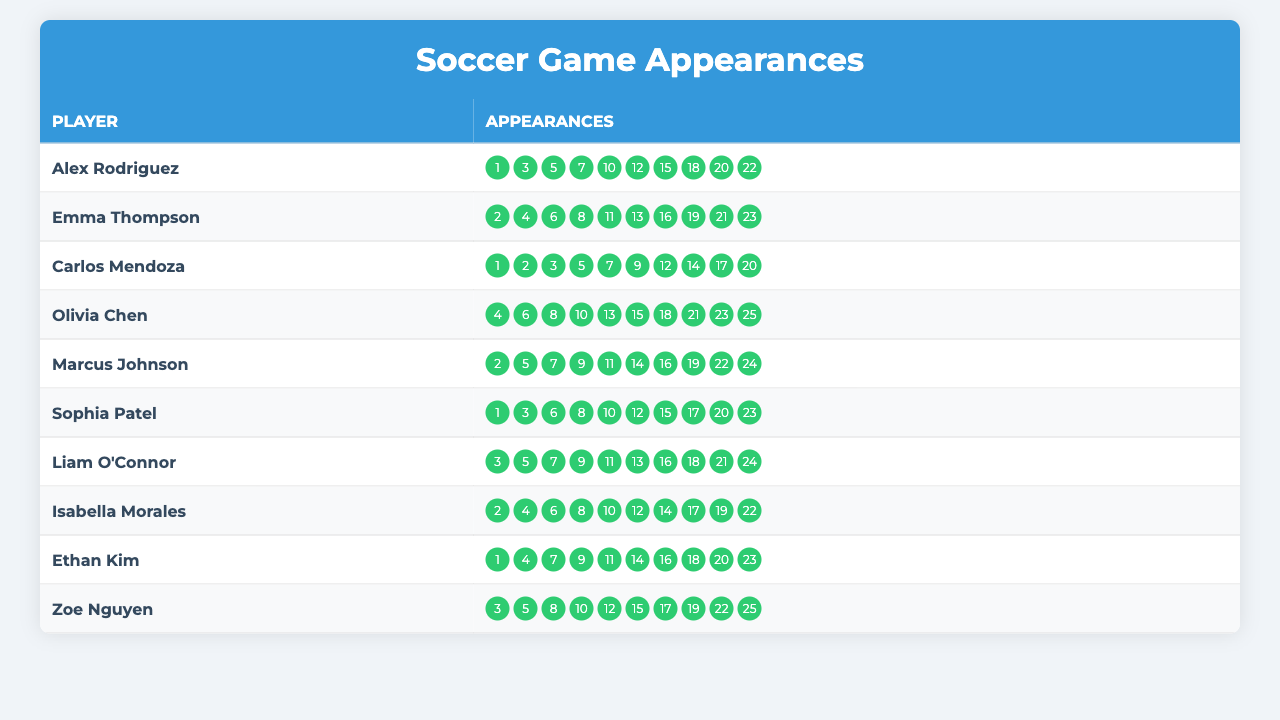What player has the highest number of appearances? By examining the "Appearances" column for each player, we can see that Olivia Chen has the highest appearance number of 25.
Answer: Olivia Chen How many appearances does Marcus Johnson have? Marcus Johnson’s appearances are listed as [2, 5, 7, 9, 11, 14, 16, 19, 22, 24]. Counting these entries, there are 10 appearances.
Answer: 10 Which player made their first appearance in game 1? Looking at the "Appearances" for each player, we find that Alex Rodriguez, Carlos Mendoza, and Sophia Patel all had their first appearances in game 1.
Answer: Alex Rodriguez, Carlos Mendoza, Sophia Patel What is the total number of appearances across all players? Adding each player's appearances gives the following: 10 (Alex) + 10 (Emma) + 10 (Carlos) + 10 (Olivia) + 10 (Marcus) + 10 (Sophia) + 10 (Liam) + 10 (Isabella) + 10 (Ethan) + 10 (Zoe) = 100.
Answer: 100 Who has the least number of appearances? Each player has the same number of appearances (10). Therefore, no player is less than any other.
Answer: None How many players had appearances in the last game (game 25)? Only Olivia Chen and Zoe Nguyen have their last appearance listed as game 25. By counting, that totals to 2 players.
Answer: 2 What is the average number of appearances per player? There are 10 players with a total of 100 appearances. The average is calculated as 100/10 = 10.
Answer: 10 Between Alex Rodriguez and Sophia Patel, who has more appearances in even-numbered games? Alex Rodriguez's even-numbered appearances are [2, 4, 6, 8, 10, 12, 14, 16, 18, 20] = 5 (2, 4, 6, 10, 12). Sophia Patel's even-numbered appearances are [2, 4, 6, 8, 10, 12, 14, 16, 18, 20] = 5 (2, 4, 6, 8, 10, 12). They each had 5 appearances in even games.
Answer: They are equal Which player has the most appearances in the first half of the season (games 1 to 12)? Counting from game 1 to 12: Alex Rodriguez 7, Emma Thompson 6, Carlos Mendoza 5, Olivia Chen 5, Marcus Johnson 5, Sophia Patel 6, Liam O'Connor 6, Isabella Morales 6, Ethan Kim 5, Zoe Nguyen 5. The maximum is 7 by Alex Rodriguez.
Answer: Alex Rodriguez How many players made appearances in games 11 and 12? Examining the appearances, Alex Rodriguez, Emma Thompson, Marcus Johnson, Liam O'Connor, and Isabella Morales made appearances in both games, totaling 5 players.
Answer: 5 What is the median number of appearances for all players? When listing out all appearances (10 for each player), the data points are [10, 10, 10, 10, 10, 10, 10, 10, 10, 10]. The median of a dataset like this is simply 10.
Answer: 10 